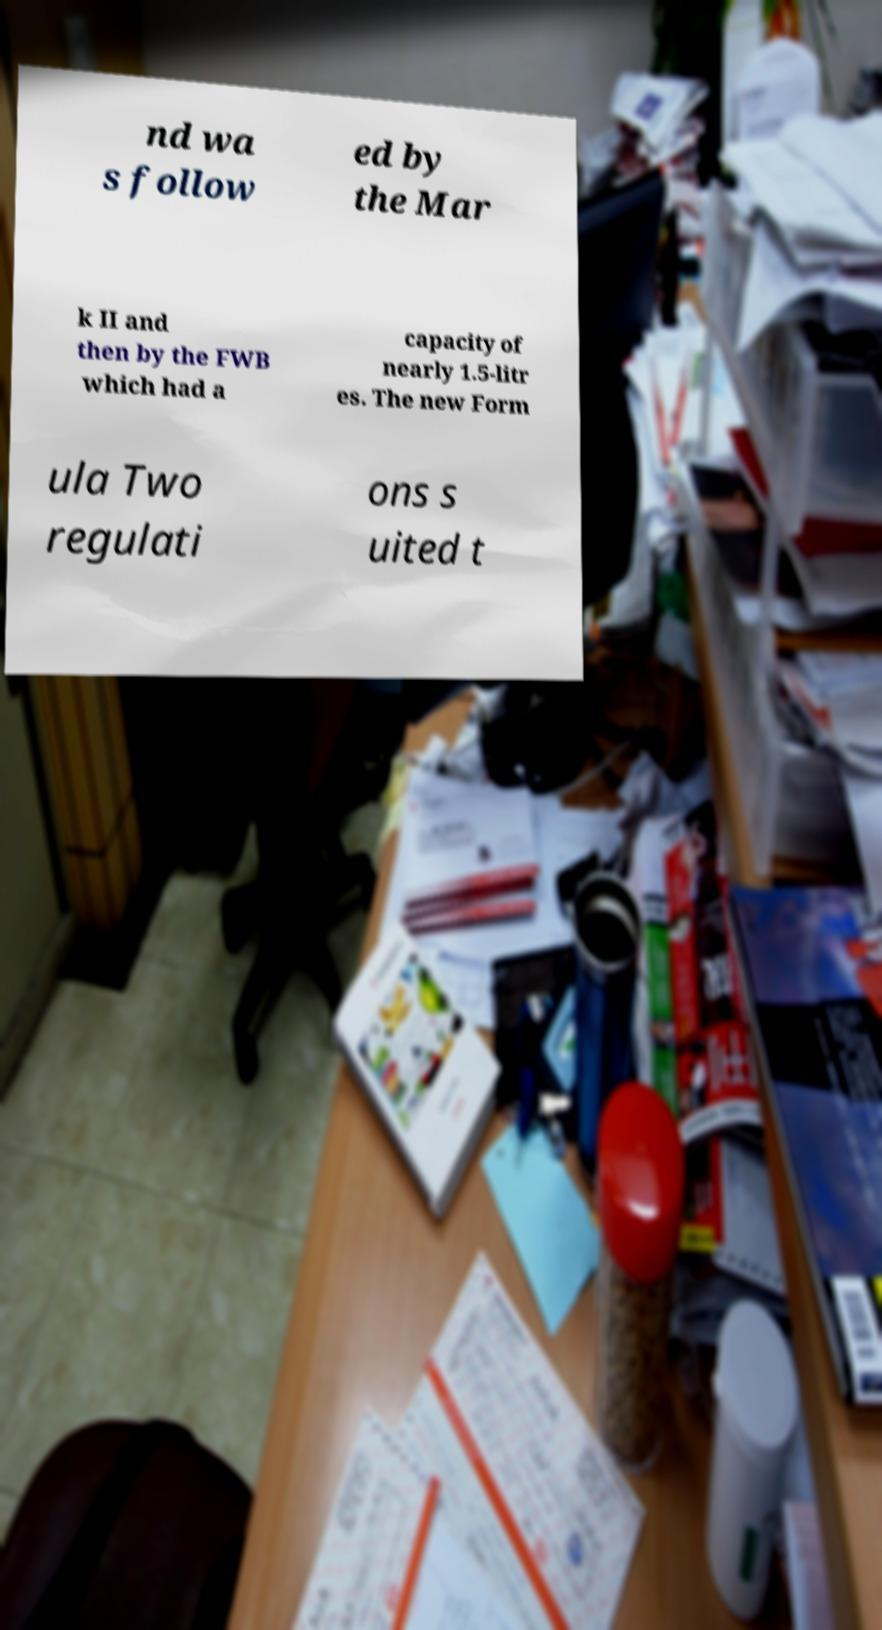There's text embedded in this image that I need extracted. Can you transcribe it verbatim? nd wa s follow ed by the Mar k II and then by the FWB which had a capacity of nearly 1.5-litr es. The new Form ula Two regulati ons s uited t 